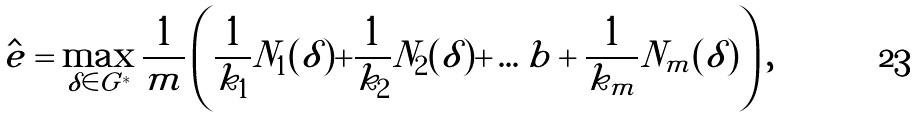<formula> <loc_0><loc_0><loc_500><loc_500>\hat { e } = \max _ { \delta \in G ^ { * } } \frac { 1 } { m } \left ( \frac { 1 } { k _ { 1 } } N _ { 1 } ( \delta ) + \frac { 1 } { k _ { 2 } } N _ { 2 } ( \delta ) + \dots b + \frac { 1 } { k _ { m } } N _ { m } ( \delta ) \right ) ,</formula> 